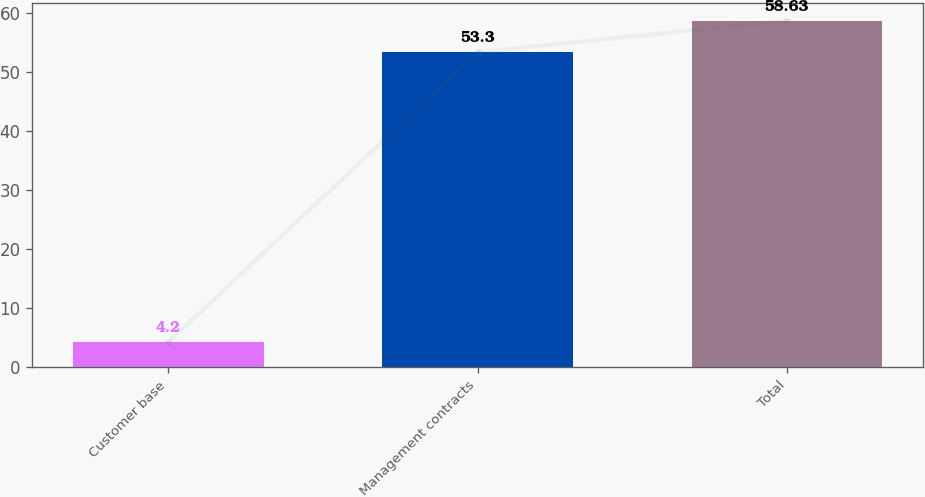Convert chart to OTSL. <chart><loc_0><loc_0><loc_500><loc_500><bar_chart><fcel>Customer base<fcel>Management contracts<fcel>Total<nl><fcel>4.2<fcel>53.3<fcel>58.63<nl></chart> 